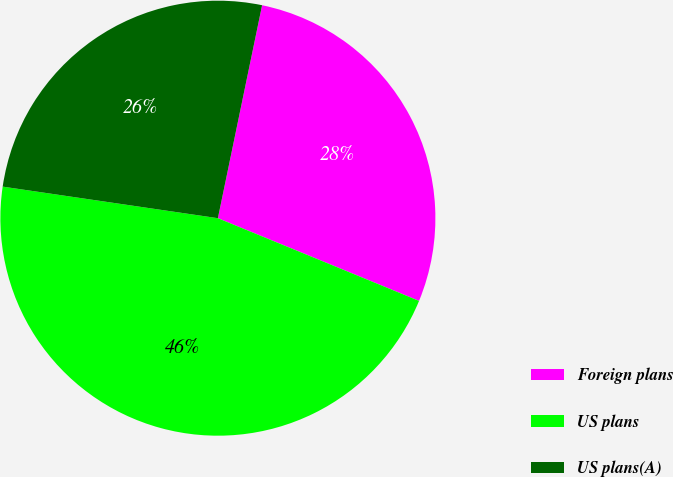Convert chart. <chart><loc_0><loc_0><loc_500><loc_500><pie_chart><fcel>Foreign plans<fcel>US plans<fcel>US plans(A)<nl><fcel>27.95%<fcel>46.11%<fcel>25.94%<nl></chart> 